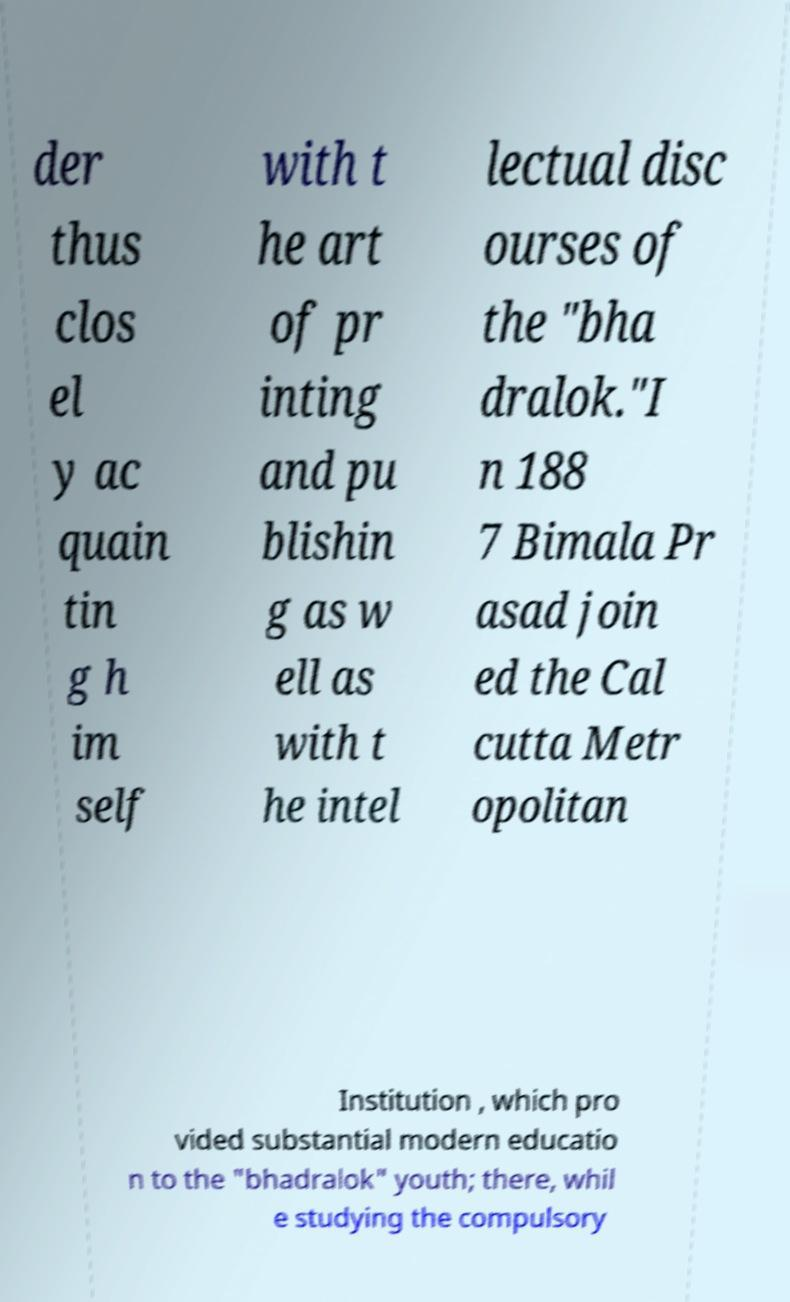Could you extract and type out the text from this image? der thus clos el y ac quain tin g h im self with t he art of pr inting and pu blishin g as w ell as with t he intel lectual disc ourses of the "bha dralok."I n 188 7 Bimala Pr asad join ed the Cal cutta Metr opolitan Institution , which pro vided substantial modern educatio n to the "bhadralok" youth; there, whil e studying the compulsory 